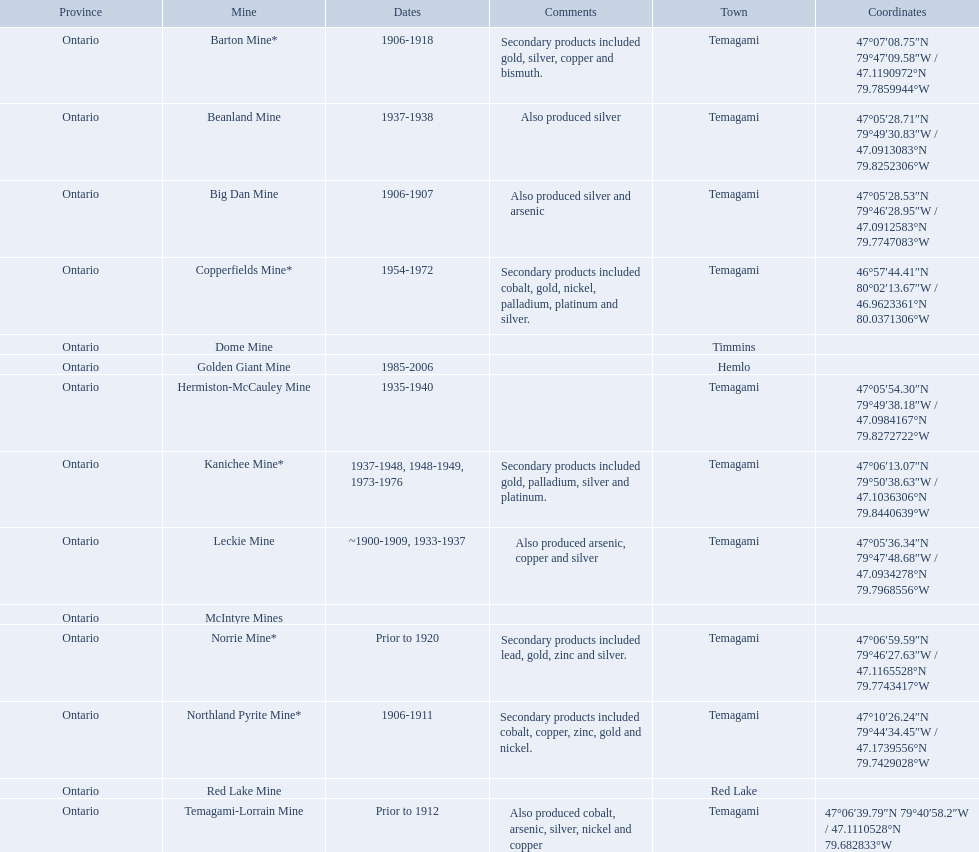What are all the mines with dates listed? Barton Mine*, Beanland Mine, Big Dan Mine, Copperfields Mine*, Golden Giant Mine, Hermiston-McCauley Mine, Kanichee Mine*, Leckie Mine, Norrie Mine*, Northland Pyrite Mine*, Temagami-Lorrain Mine. Which of those dates include the year that the mine was closed? 1906-1918, 1937-1938, 1906-1907, 1954-1972, 1985-2006, 1935-1940, 1937-1948, 1948-1949, 1973-1976, ~1900-1909, 1933-1937, 1906-1911. Which of those mines were opened the longest? Golden Giant Mine. 